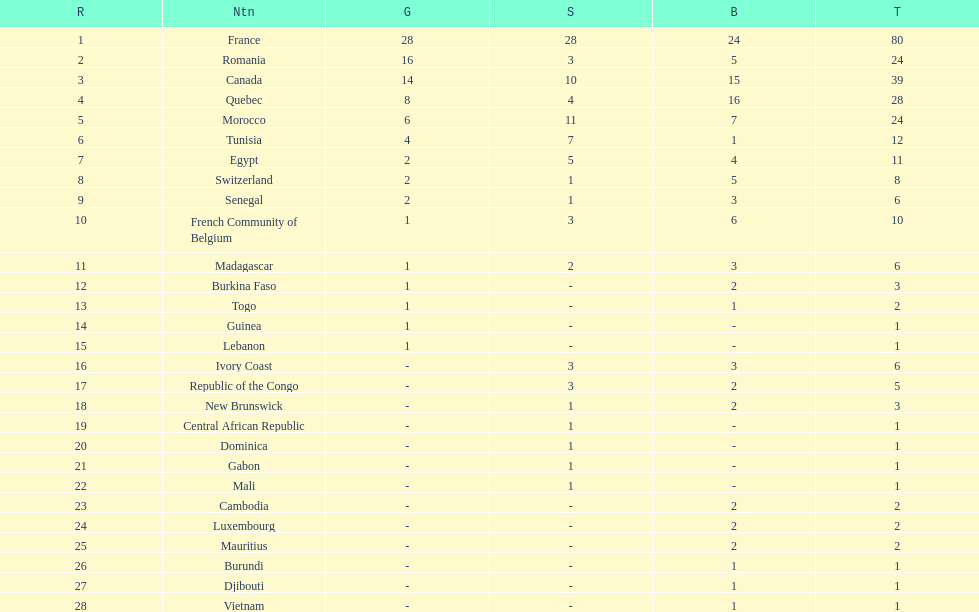How many nations won at least 10 medals? 8. 